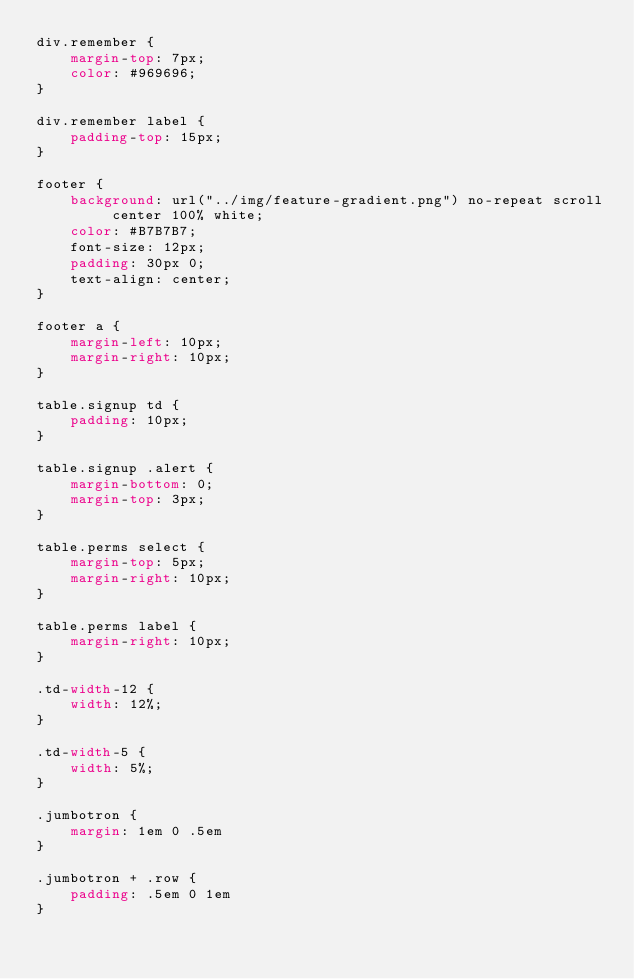<code> <loc_0><loc_0><loc_500><loc_500><_CSS_>div.remember {
    margin-top: 7px;
    color: #969696;
}

div.remember label {
    padding-top: 15px;
}

footer {
    background: url("../img/feature-gradient.png") no-repeat scroll center 100% white;
    color: #B7B7B7;
    font-size: 12px;
    padding: 30px 0;
    text-align: center;
}

footer a {
    margin-left: 10px;
    margin-right: 10px;
}

table.signup td {
    padding: 10px;
}

table.signup .alert {
    margin-bottom: 0;
    margin-top: 3px;
}

table.perms select {
    margin-top: 5px;
    margin-right: 10px;
}

table.perms label {
    margin-right: 10px;
}

.td-width-12 {
    width: 12%;
}

.td-width-5 {
    width: 5%;
}

.jumbotron {
    margin: 1em 0 .5em
}

.jumbotron + .row {
    padding: .5em 0 1em
}
</code> 